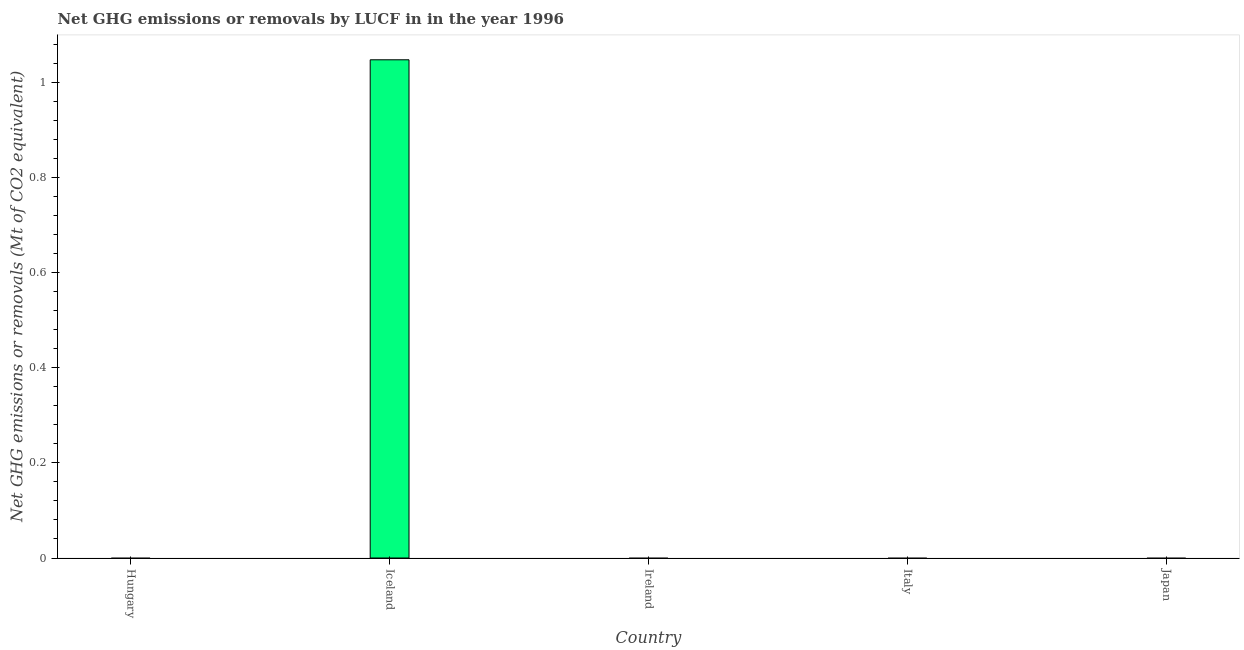Does the graph contain grids?
Provide a succinct answer. No. What is the title of the graph?
Your answer should be very brief. Net GHG emissions or removals by LUCF in in the year 1996. What is the label or title of the X-axis?
Provide a short and direct response. Country. What is the label or title of the Y-axis?
Offer a terse response. Net GHG emissions or removals (Mt of CO2 equivalent). Across all countries, what is the maximum ghg net emissions or removals?
Your response must be concise. 1.05. In which country was the ghg net emissions or removals maximum?
Make the answer very short. Iceland. What is the sum of the ghg net emissions or removals?
Provide a succinct answer. 1.05. What is the average ghg net emissions or removals per country?
Your answer should be compact. 0.21. What is the median ghg net emissions or removals?
Your response must be concise. 0. In how many countries, is the ghg net emissions or removals greater than 0.36 Mt?
Offer a terse response. 1. In how many countries, is the ghg net emissions or removals greater than the average ghg net emissions or removals taken over all countries?
Your response must be concise. 1. How many countries are there in the graph?
Offer a terse response. 5. What is the difference between two consecutive major ticks on the Y-axis?
Your answer should be compact. 0.2. Are the values on the major ticks of Y-axis written in scientific E-notation?
Your answer should be very brief. No. What is the Net GHG emissions or removals (Mt of CO2 equivalent) of Hungary?
Your answer should be compact. 0. What is the Net GHG emissions or removals (Mt of CO2 equivalent) in Iceland?
Offer a terse response. 1.05. 